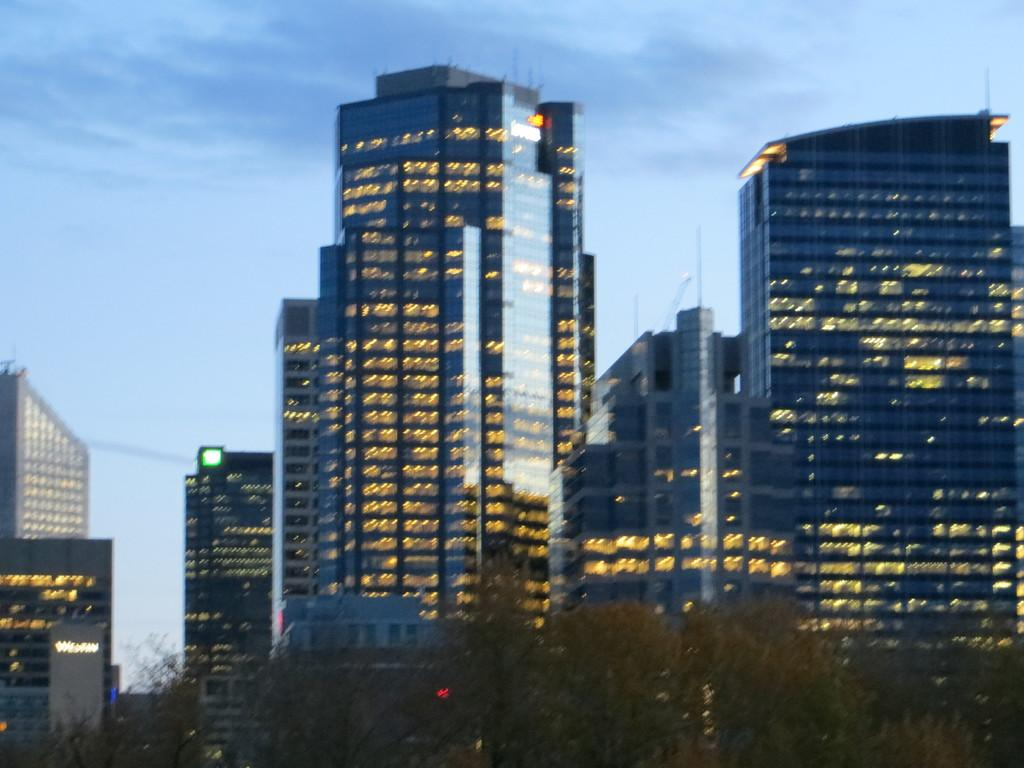What is the main subject of the image? The main subject of the image is buildings with lights in the center. What can be seen at the bottom of the image? There are trees at the bottom of the image. What is visible at the top of the image? The sky is visible at the top of the image. What type of statement can be seen written on the sofa in the image? There is no sofa present in the image, so it is not possible to answer that question. 